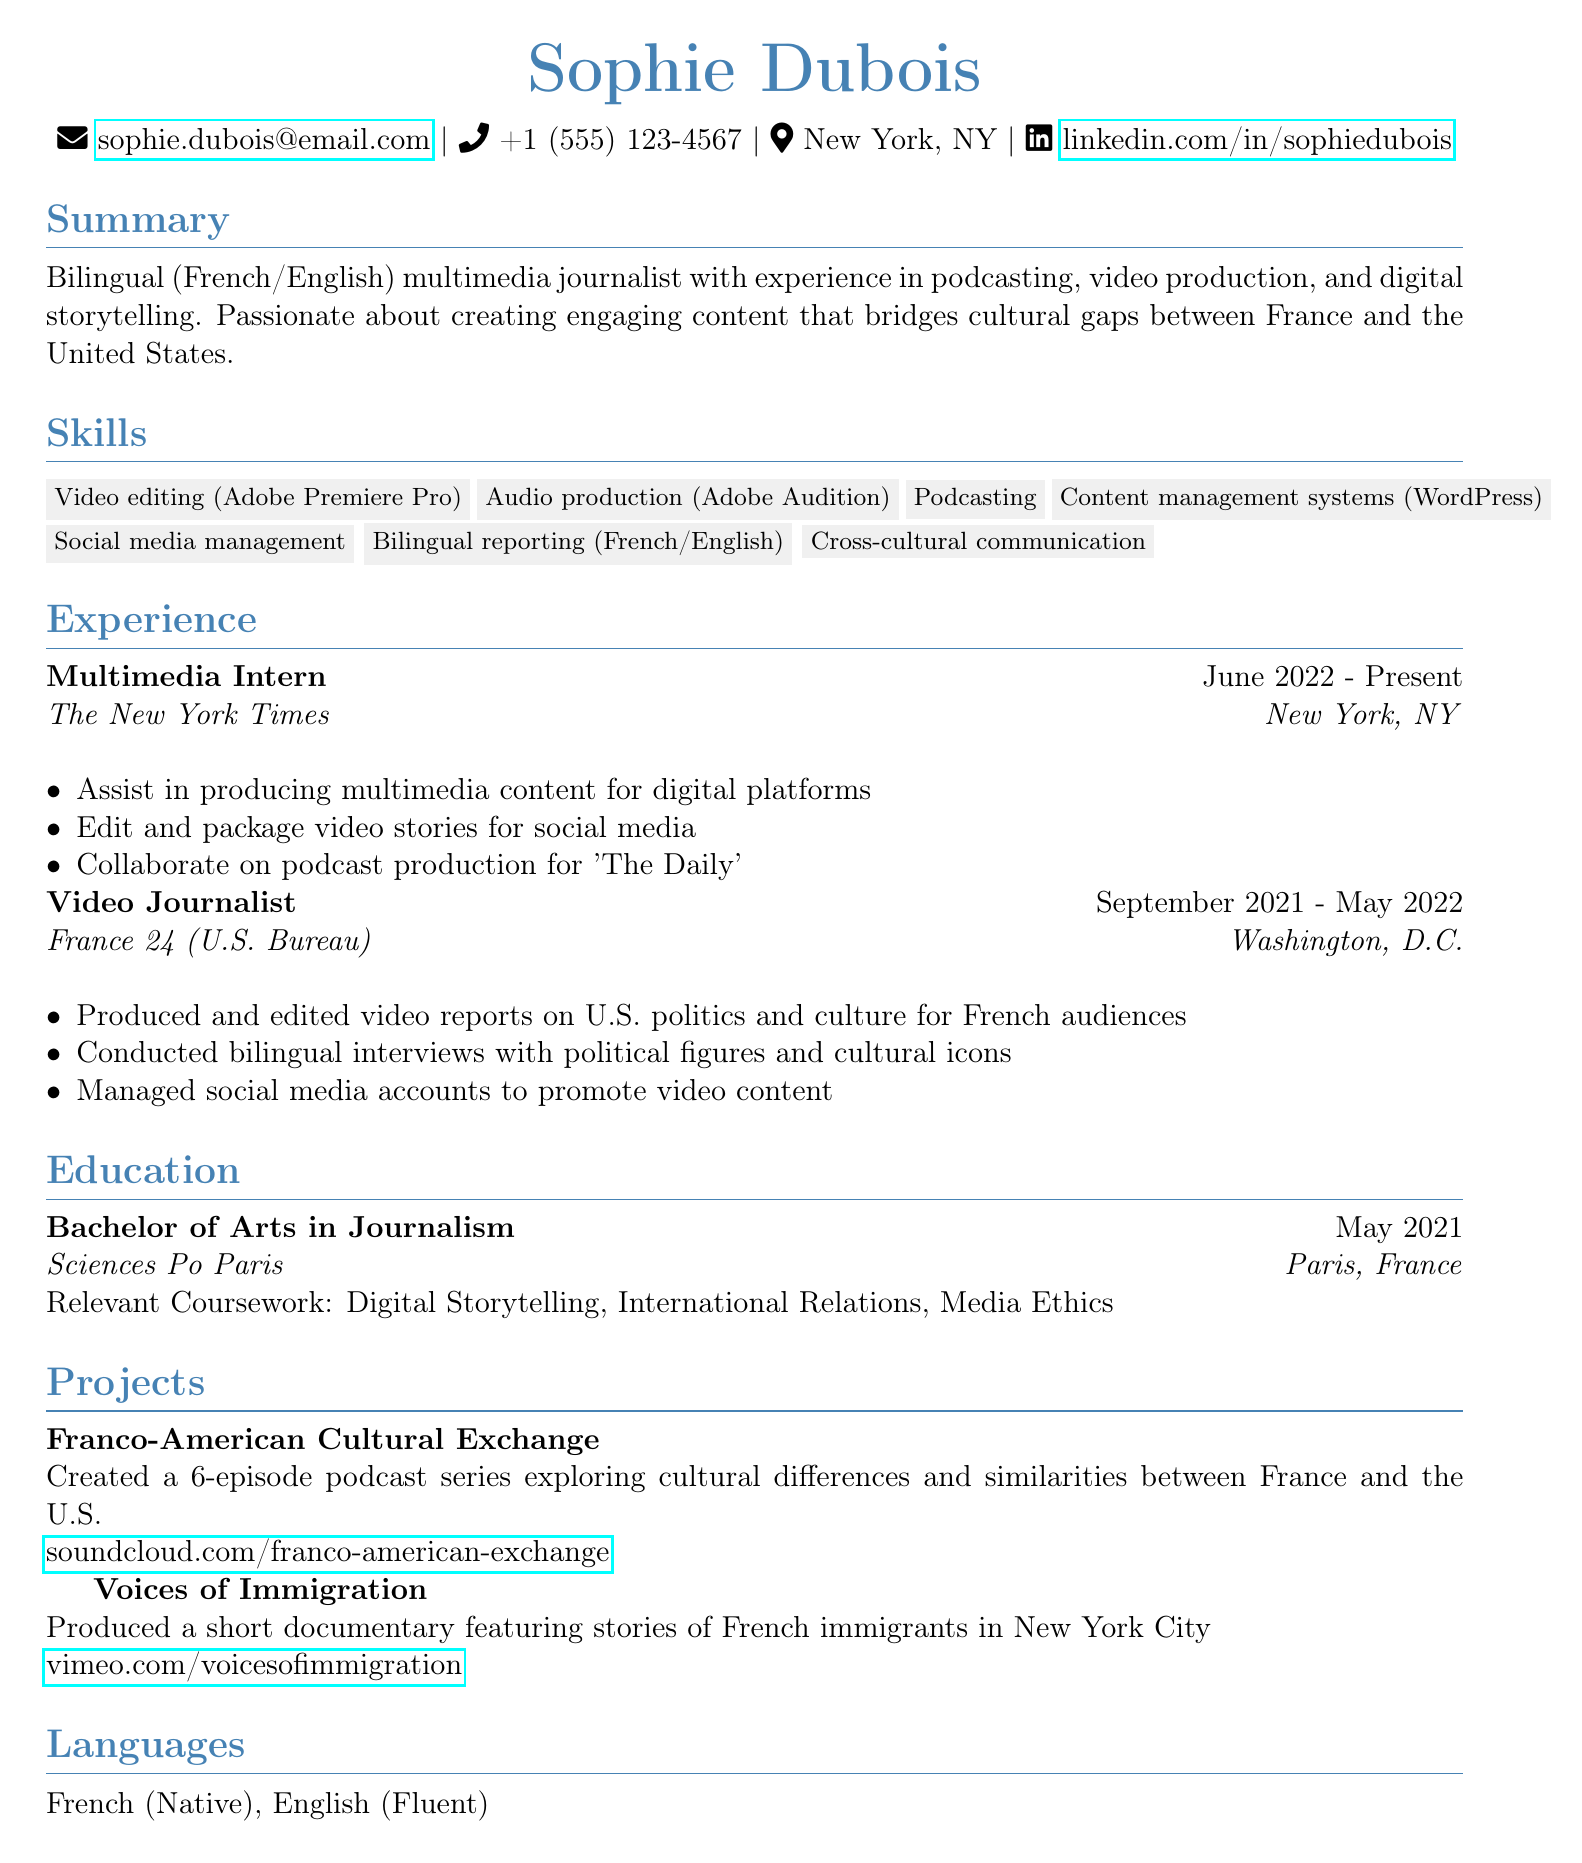what is the name of the individual? The name is listed at the top of the document under personal information.
Answer: Sophie Dubois how long has Sophie been a multimedia intern at The New York Times? The duration is indicated under her experience section, specifically mentioning the dates of employment.
Answer: Since June 2022 which degree did Sophie earn? The degree obtained is specified in the education section of the document.
Answer: Bachelor of Arts in Journalism what is the title of the podcast series Sophie created? The title is provided in the projects section, where her podcast series is mentioned.
Answer: Franco-American Cultural Exchange in which city is Sophie's current internship located? The city is given under the experience section for her internship job.
Answer: New York, NY how many episodes are in the podcast series created by Sophie? The number of episodes is detailed in the description of the podcast project.
Answer: 6 who did Sophie collaborate with on the podcast production for The Daily? The collaboration information is provided under her responsibilities in the internship section.
Answer: Colleagues at The New York Times what is one of the skills listed in Sophie's skills section? The skills are listed in a specific section of the document, each separated by a comma.
Answer: Podcasting which social media platform hosts the podcast series? The hosting platform for the podcast is mentioned in the project description.
Answer: SoundCloud 